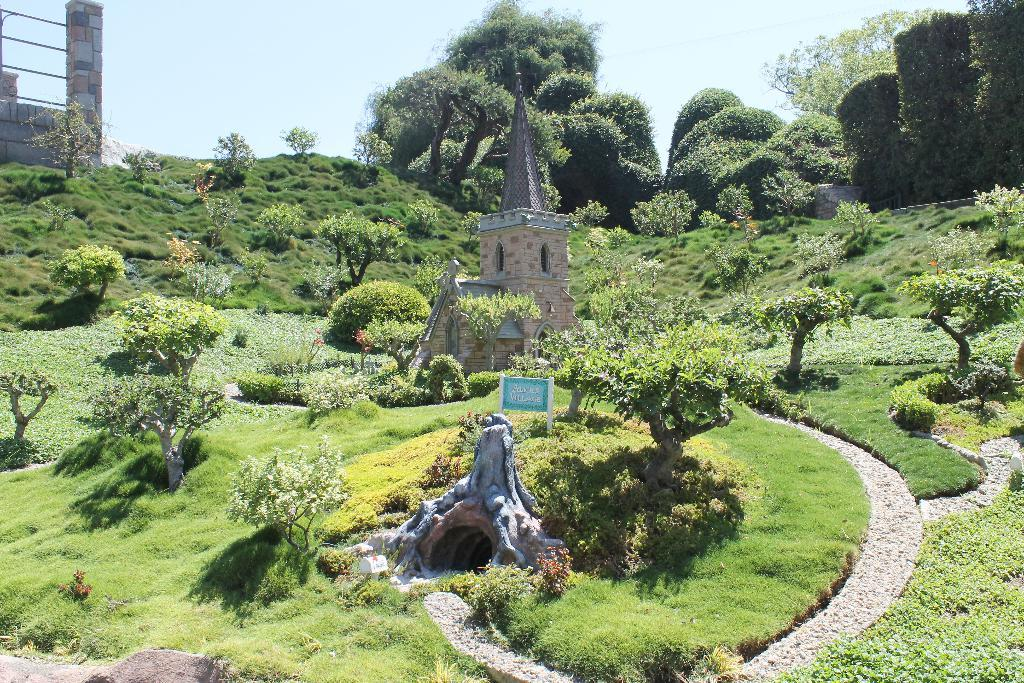What type of structure is visible in the image? There is a building with windows in the image. What other objects can be seen in the image? There is a statue, a signboard, a group of trees, plants, grass, and a pillar with metal poles in the image. What is visible in the sky in the image? The sky is visible in the image. How many dinosaurs are present in the image? There are no dinosaurs present in the image. What type of sleep can be observed in the image? There is no sleep depicted in the image. 